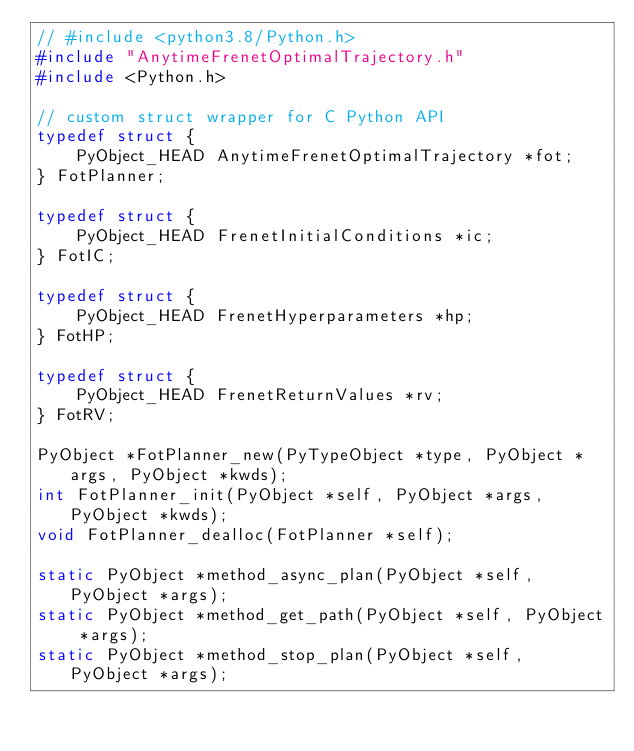Convert code to text. <code><loc_0><loc_0><loc_500><loc_500><_C_>// #include <python3.8/Python.h>
#include "AnytimeFrenetOptimalTrajectory.h"
#include <Python.h>

// custom struct wrapper for C Python API
typedef struct {
    PyObject_HEAD AnytimeFrenetOptimalTrajectory *fot;
} FotPlanner;

typedef struct {
    PyObject_HEAD FrenetInitialConditions *ic;
} FotIC;

typedef struct {
    PyObject_HEAD FrenetHyperparameters *hp;
} FotHP;

typedef struct {
    PyObject_HEAD FrenetReturnValues *rv;
} FotRV;

PyObject *FotPlanner_new(PyTypeObject *type, PyObject *args, PyObject *kwds);
int FotPlanner_init(PyObject *self, PyObject *args, PyObject *kwds);
void FotPlanner_dealloc(FotPlanner *self);

static PyObject *method_async_plan(PyObject *self, PyObject *args);
static PyObject *method_get_path(PyObject *self, PyObject *args);
static PyObject *method_stop_plan(PyObject *self, PyObject *args);</code> 